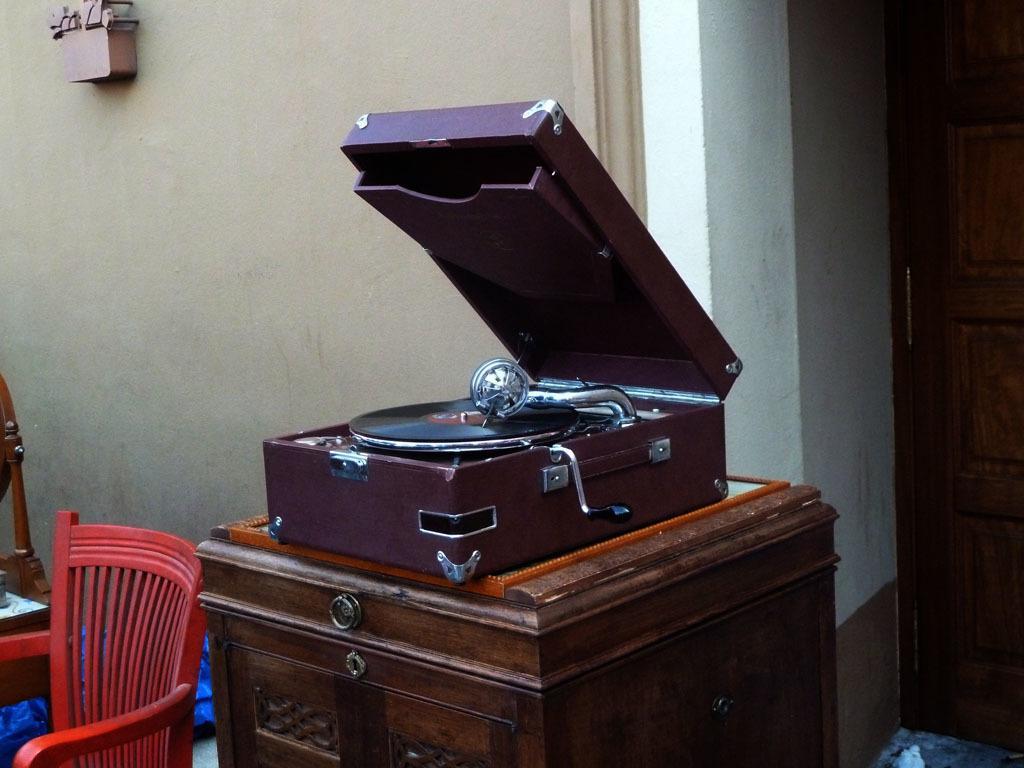Please provide a concise description of this image. In this picture we can see a gramophone cabinet. There is a chair on the right side. We can see an object on the wall. A door is visible in the background. 